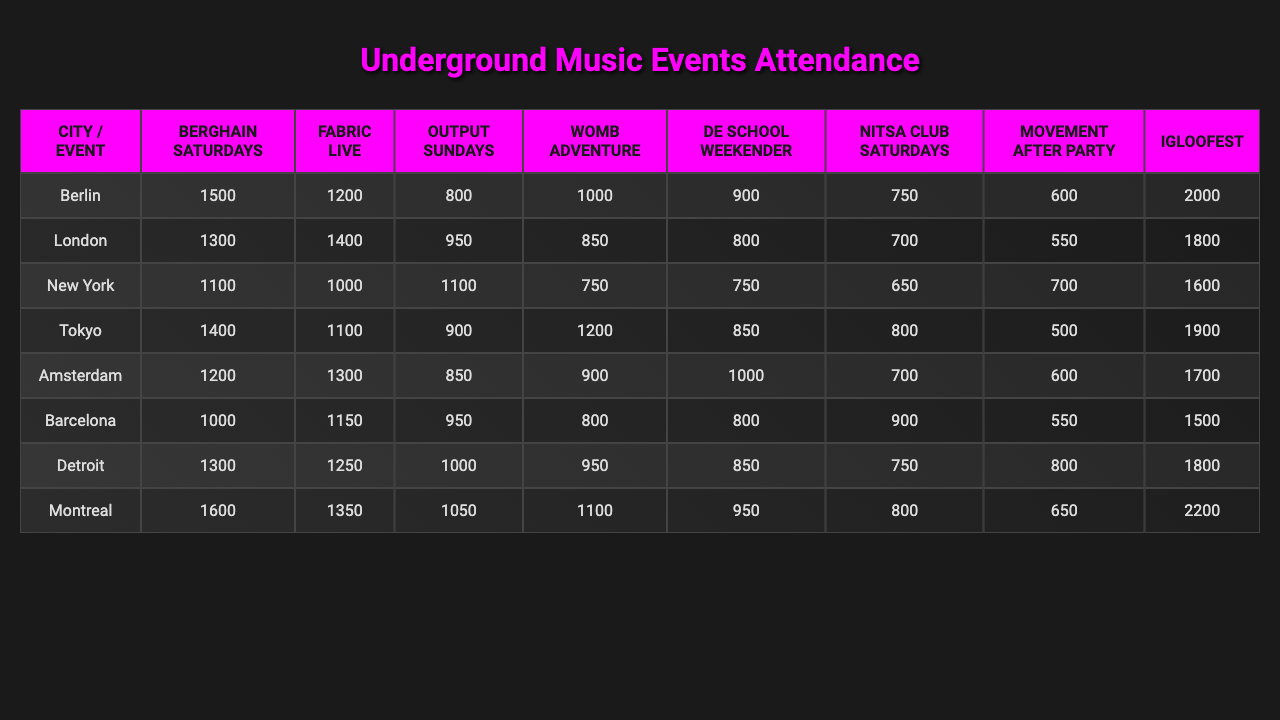What is the highest attendance recorded for an event in Berlin? Looking at the Berlin row, the event with the highest attendance is "Berghain Saturdays," with 1500 attendees.
Answer: 1500 Which city has the lowest average attendance for the listed events? To find the city with the lowest average, we must calculate the average attendance for each city. The averages are: Berlin (1088.75), London (1043.75), New York (1050), Tokyo (1012.5), Amsterdam (975), Barcelona (887.5), Detroit (944.44), and Montreal (1137.5). Amsterdam has the lowest average attendance.
Answer: Amsterdam Did any event in New York have a higher attendance than 1200? Checking the New York row, "Output Sundays" had 1100 attendees, and no other event surpassed 1200 attendees. Therefore, none did.
Answer: No What is the difference in attendance between the highest and lowest attended events in Amsterdam? The highest attended event in Amsterdam is "Igloofest" with 1700 attendees, while the lowest is "Nitsa Club Saturdays" with 700. Therefore, the difference is 1700 - 700 = 1000.
Answer: 1000 Which event had the highest overall attendance across all cities? We will sum the attendance for each event across all cities: "Berghain Saturdays" (1500 + 1300 + 1100 + 1400 + 1200 + 1000 + 1300 + 1600 = 11500), "Fabric Live" (1200 + 1400 + 1000 + 1100 + 1300 + 1150 + 1250 + 1350 = 11500), "Output Sundays" (800 + 950 + 1100 + 900 + 850 + 950 + 1000 + 1050 = 7250), "Womb Adventure" (1000 + 850 + 750 + 1200 + 900 + 800 + 950 + 1100 = 6700), "De School Weekender" (900 + 800 + 750 + 850 + 1000 + 800 + 850 + 950 = 6650), "Nitsa Club Saturdays" (750 + 700 + 650 + 800 + 700 + 900 + 750 + 800 = 6250), "Movement After Party" (600 + 550 + 700 + 500 + 600 + 550 + 800 + 650 = 4500), "Igloofest" (2000 + 1800 + 1600 + 1900 + 1700 + 1500 + 1800 + 2200 = 15500). "Igloofest" has the highest attendance with 15500.
Answer: Igloofest Which city had the maximum attendance for "Womb Adventure"? In the "Womb Adventure" column, we can see the attendance numbers: Berlin (1000), London (850), New York (750), Tokyo (1200), Amsterdam (900), Barcelona (800), Detroit (950), Montreal (1100). Tokyo has the maximum attendance of 1200 for this event.
Answer: Tokyo What is the average attendance for "Fabric Live"? To calculate the average attendance for "Fabric Live", we sum the attendance across the cities: (1200 + 1400 + 1000 + 1100 + 1300 + 1150 + 1250 + 1350 = 11500). There are 8 cities, so the average is 11500/8 = 1437.5.
Answer: 1437.5 Which event had the second highest attendance in Detroit? Reviewing the Detroit row, the attendance numbers for events are: 1300 for "Berghain Saturdays," 1250 for "Fabric Live," 1000 for "Output Sundays," 950 for "Womb Adventure," 850 for "De School Weekender," 750 for "Nitsa Club Saturdays," 800 for "Movement After Party," and 1800 for "Igloofest." The second highest is 1250 for "Fabric Live."
Answer: Fabric Live 